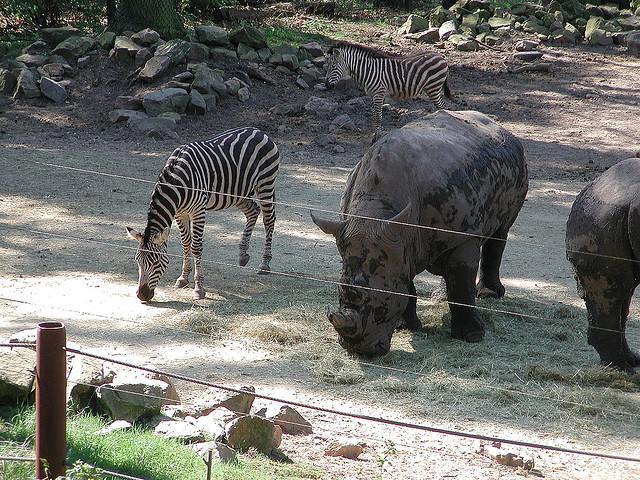What are the animals eating?
Concise answer only. Hay. IS it sunny?
Short answer required. Yes. How many types of animals are represented?
Quick response, please. 2. 